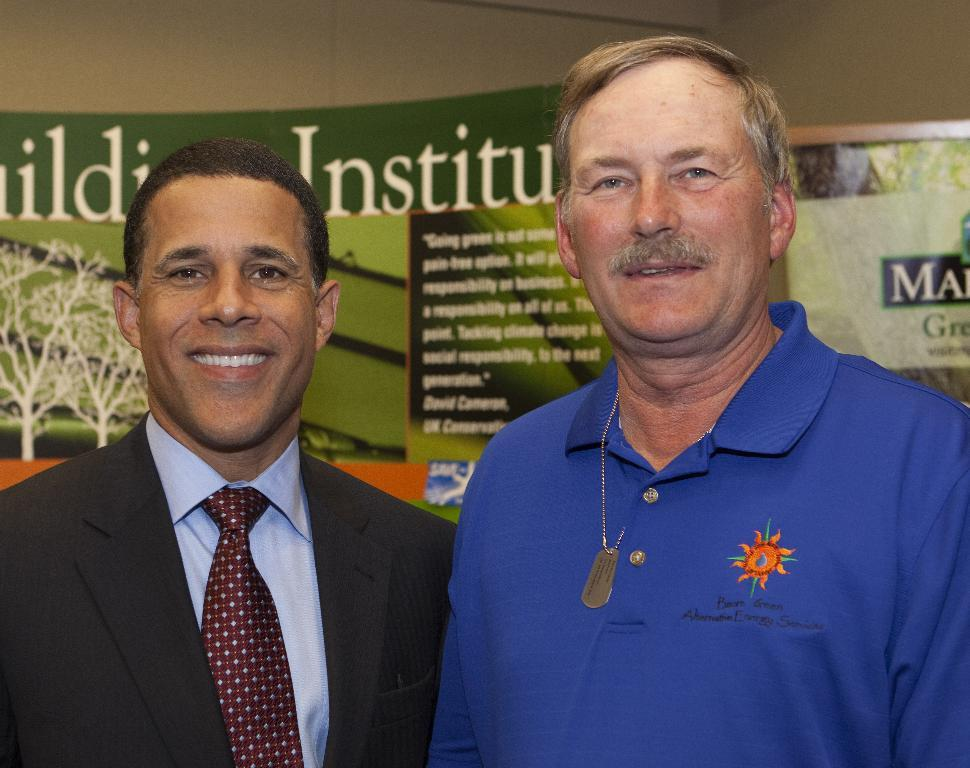How many people are in the image? There are two men in the image. What is the facial expression of the men in the image? The men are smiling. What can be seen in the background of the image? There are banners and a wall visible in the background of the image. What type of servant is standing next to the men in the image? There is no servant present in the image; it only features two men. What type of spade is being used by the men in the image? There is no spade present in the image; the men are not holding or using any tools. 